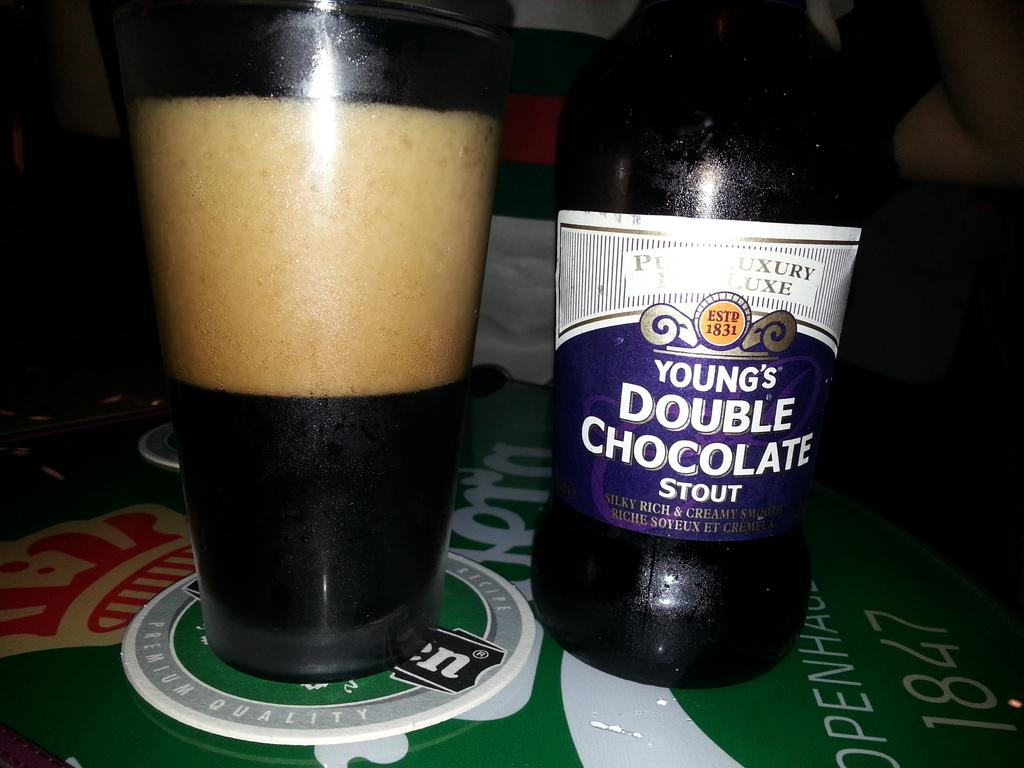Provide a one-sentence caption for the provided image. Young's Double Chocolate Stout is poured into a glass next to the bottle. 